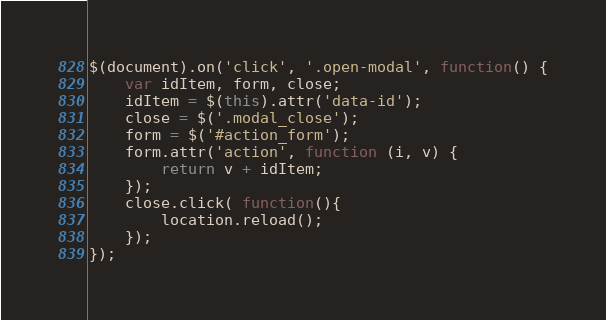Convert code to text. <code><loc_0><loc_0><loc_500><loc_500><_JavaScript_>$(document).on('click', '.open-modal', function() {
    var idItem, form, close;
    idItem = $(this).attr('data-id');
    close = $('.modal_close');
    form = $('#action_form');
    form.attr('action', function (i, v) {
        return v + idItem;
    });
    close.click( function(){
        location.reload();
    });
});
</code> 